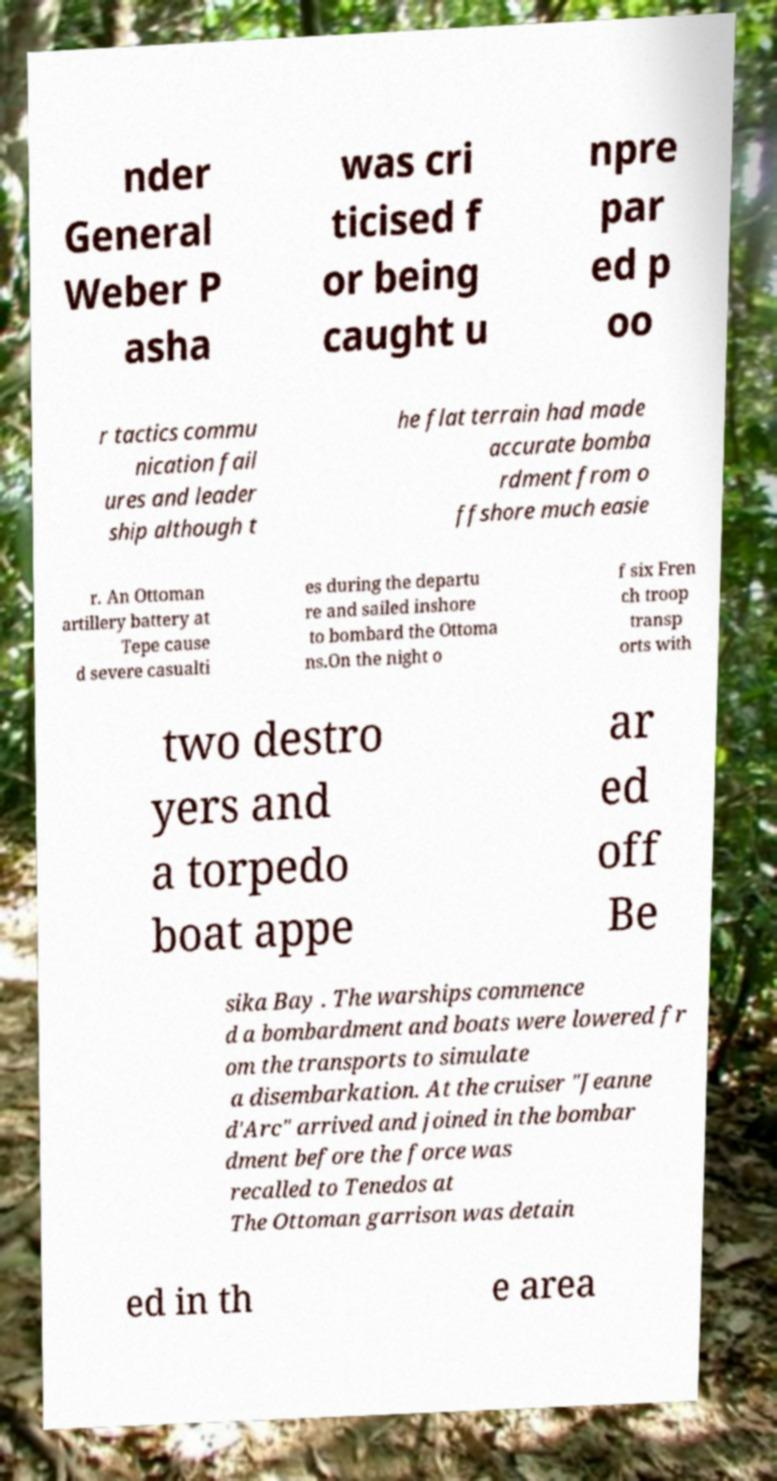Please identify and transcribe the text found in this image. nder General Weber P asha was cri ticised f or being caught u npre par ed p oo r tactics commu nication fail ures and leader ship although t he flat terrain had made accurate bomba rdment from o ffshore much easie r. An Ottoman artillery battery at Tepe cause d severe casualti es during the departu re and sailed inshore to bombard the Ottoma ns.On the night o f six Fren ch troop transp orts with two destro yers and a torpedo boat appe ar ed off Be sika Bay . The warships commence d a bombardment and boats were lowered fr om the transports to simulate a disembarkation. At the cruiser "Jeanne d'Arc" arrived and joined in the bombar dment before the force was recalled to Tenedos at The Ottoman garrison was detain ed in th e area 